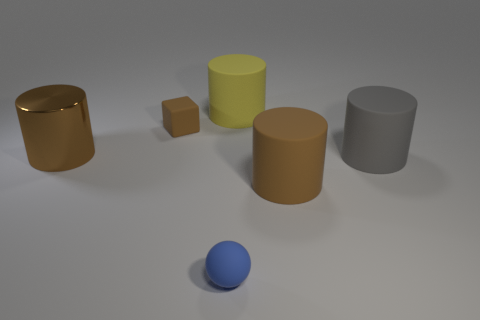There is a block that is made of the same material as the tiny blue thing; what color is it?
Offer a terse response. Brown. There is a brown matte thing that is in front of the gray thing; what number of tiny brown objects are left of it?
Offer a terse response. 1. What is the material of the brown object that is in front of the brown matte block and on the left side of the big yellow matte cylinder?
Your answer should be compact. Metal. Does the gray matte object behind the large brown rubber thing have the same shape as the small blue thing?
Provide a short and direct response. No. Are there fewer big rubber things than cylinders?
Offer a terse response. Yes. How many large metallic cylinders are the same color as the block?
Your answer should be very brief. 1. There is a large shiny object; is its color the same as the cylinder that is in front of the gray cylinder?
Your answer should be compact. Yes. Are there more tiny rubber objects than big objects?
Your answer should be very brief. No. What is the size of the yellow rubber thing that is the same shape as the large brown rubber object?
Offer a very short reply. Large. Is the material of the tiny brown block the same as the brown thing that is on the right side of the big yellow object?
Give a very brief answer. Yes. 